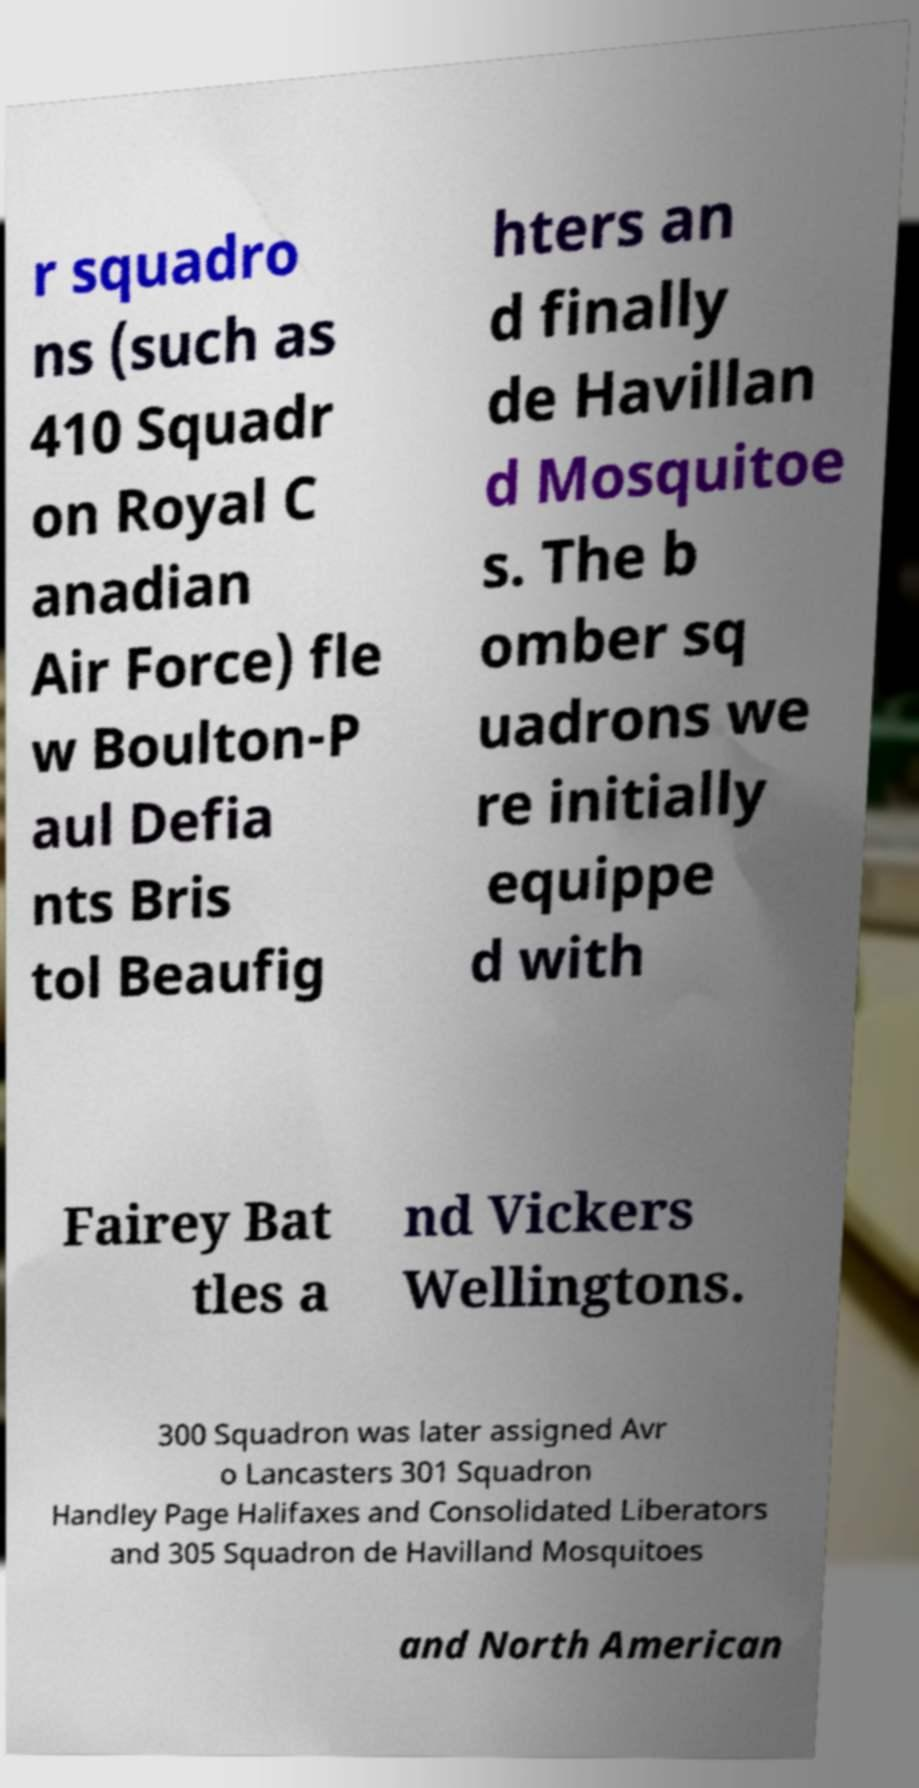What messages or text are displayed in this image? I need them in a readable, typed format. r squadro ns (such as 410 Squadr on Royal C anadian Air Force) fle w Boulton-P aul Defia nts Bris tol Beaufig hters an d finally de Havillan d Mosquitoe s. The b omber sq uadrons we re initially equippe d with Fairey Bat tles a nd Vickers Wellingtons. 300 Squadron was later assigned Avr o Lancasters 301 Squadron Handley Page Halifaxes and Consolidated Liberators and 305 Squadron de Havilland Mosquitoes and North American 